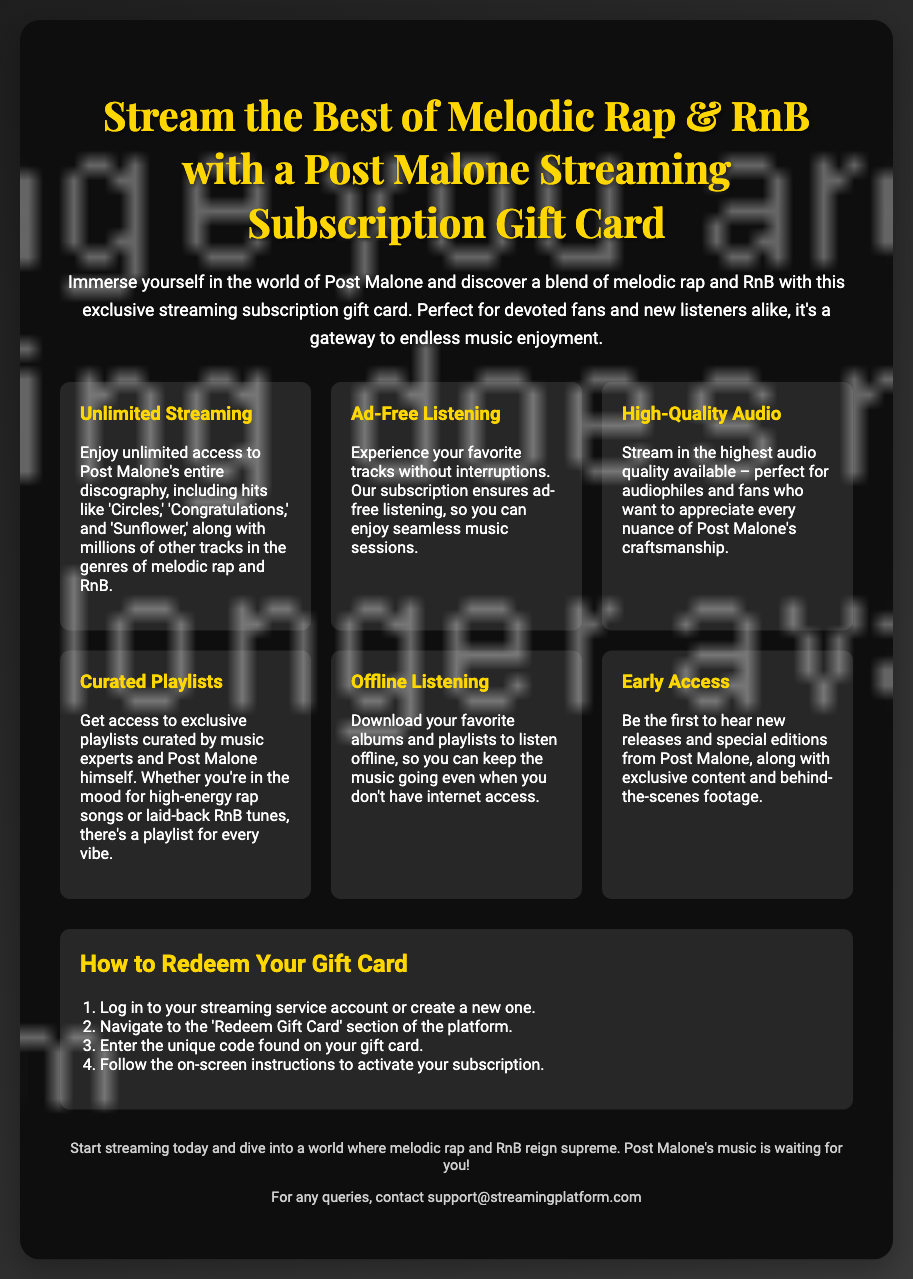What is the title of the gift card? The title of the gift card is displayed prominently at the top of the document.
Answer: Stream the Best of Melodic Rap & RnB with a Post Malone Streaming Subscription Gift Card How many features are listed in the document? The features section describes the benefits of the gift card, which includes several aspects related to streaming.
Answer: Six What genre of music does the gift card focus on? The introductory paragraph defines the main genre of music that the gift card is associated with.
Answer: Melodic rap and RnB What does the gift card allow you to enjoy? The introduction highlights what the gift card provides access to in terms of music.
Answer: Unlimited streaming What is the purpose of the gift card? The introduction explains the primary utility or purpose of the gift card.
Answer: A gateway to endless music enjoyment What should you do first to redeem the gift card? The steps for redeeming the gift card specifically mention the initial action required for redemption.
Answer: Log in to your streaming service account What is a benefit of having the subscription in terms of ads? One of the features outlines the experience offered by the subscription regarding advertisements.
Answer: Ad-free listening What type of playlists can you access with the gift card? The feature section indicates the kind of playlists available to subscribers.
Answer: Curated playlists What is the contact email for queries? The footer of the document provides a contact email for any questions or issues.
Answer: support@streamingplatform.com 